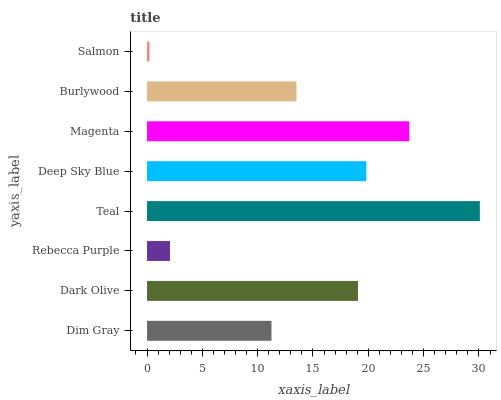Is Salmon the minimum?
Answer yes or no. Yes. Is Teal the maximum?
Answer yes or no. Yes. Is Dark Olive the minimum?
Answer yes or no. No. Is Dark Olive the maximum?
Answer yes or no. No. Is Dark Olive greater than Dim Gray?
Answer yes or no. Yes. Is Dim Gray less than Dark Olive?
Answer yes or no. Yes. Is Dim Gray greater than Dark Olive?
Answer yes or no. No. Is Dark Olive less than Dim Gray?
Answer yes or no. No. Is Dark Olive the high median?
Answer yes or no. Yes. Is Burlywood the low median?
Answer yes or no. Yes. Is Burlywood the high median?
Answer yes or no. No. Is Rebecca Purple the low median?
Answer yes or no. No. 